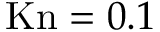<formula> <loc_0><loc_0><loc_500><loc_500>K n = 0 . 1</formula> 